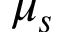<formula> <loc_0><loc_0><loc_500><loc_500>\mu _ { s }</formula> 